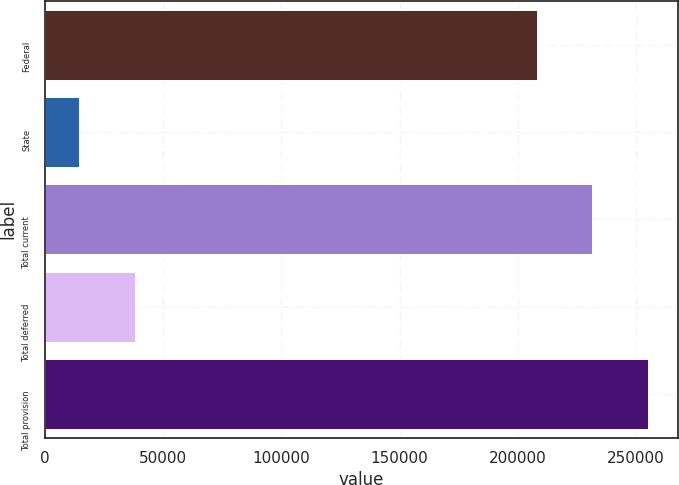<chart> <loc_0><loc_0><loc_500><loc_500><bar_chart><fcel>Federal<fcel>State<fcel>Total current<fcel>Total deferred<fcel>Total provision<nl><fcel>207986<fcel>14516<fcel>231527<fcel>38056.8<fcel>255068<nl></chart> 